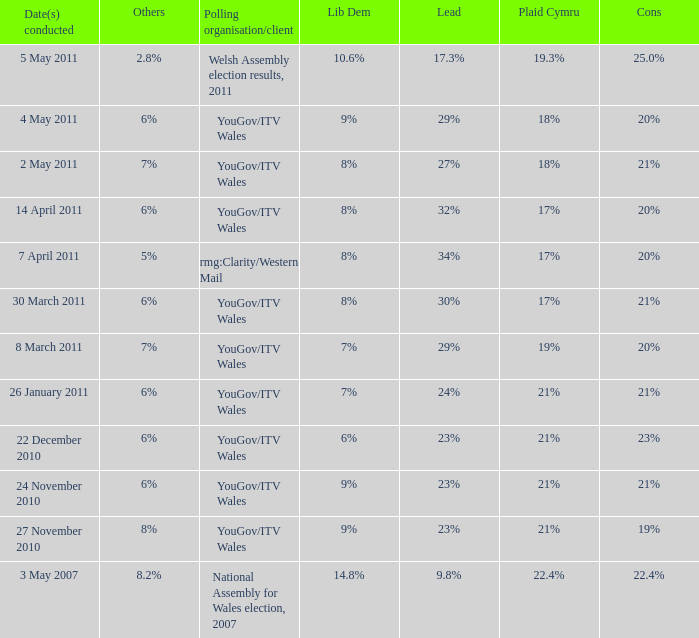Tell me the dates conducted for plaid cymru of 19% 8 March 2011. 